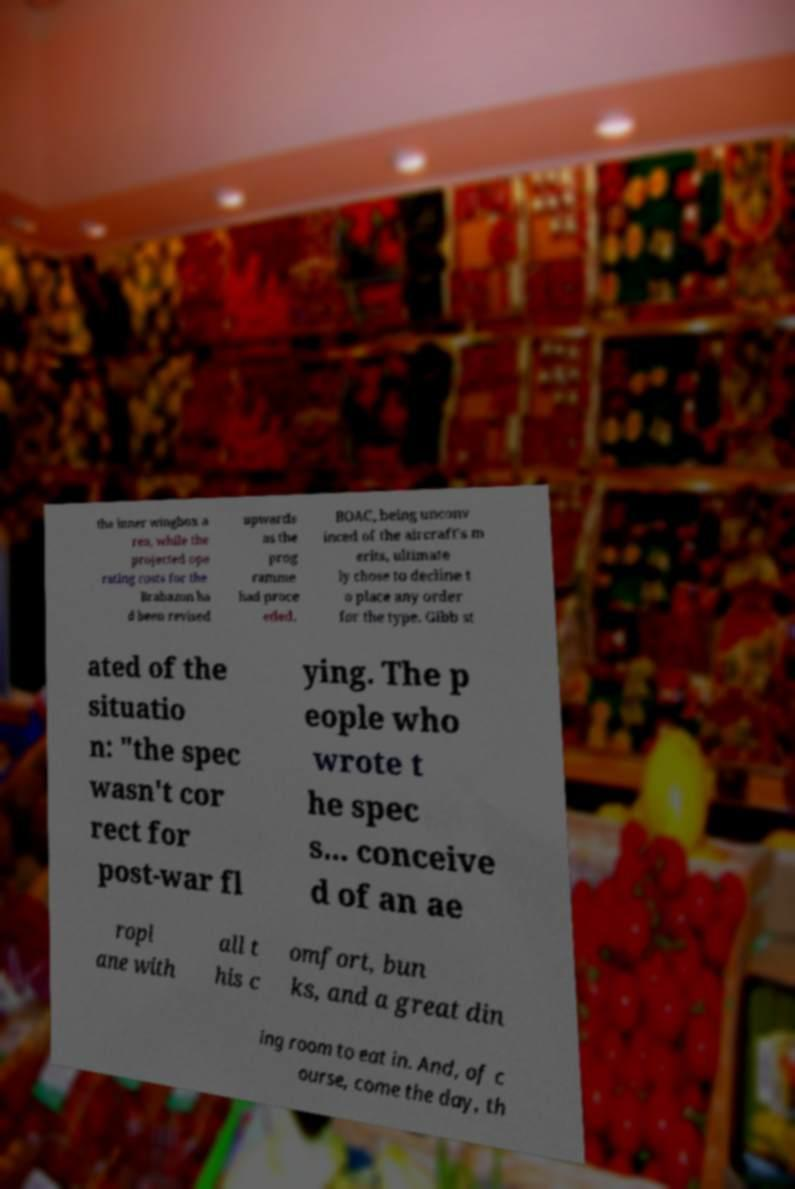What messages or text are displayed in this image? I need them in a readable, typed format. the inner wingbox a rea, while the projected ope rating costs for the Brabazon ha d been revised upwards as the prog ramme had proce eded. BOAC, being unconv inced of the aircraft's m erits, ultimate ly chose to decline t o place any order for the type. Gibb st ated of the situatio n: "the spec wasn't cor rect for post-war fl ying. The p eople who wrote t he spec s... conceive d of an ae ropl ane with all t his c omfort, bun ks, and a great din ing room to eat in. And, of c ourse, come the day, th 